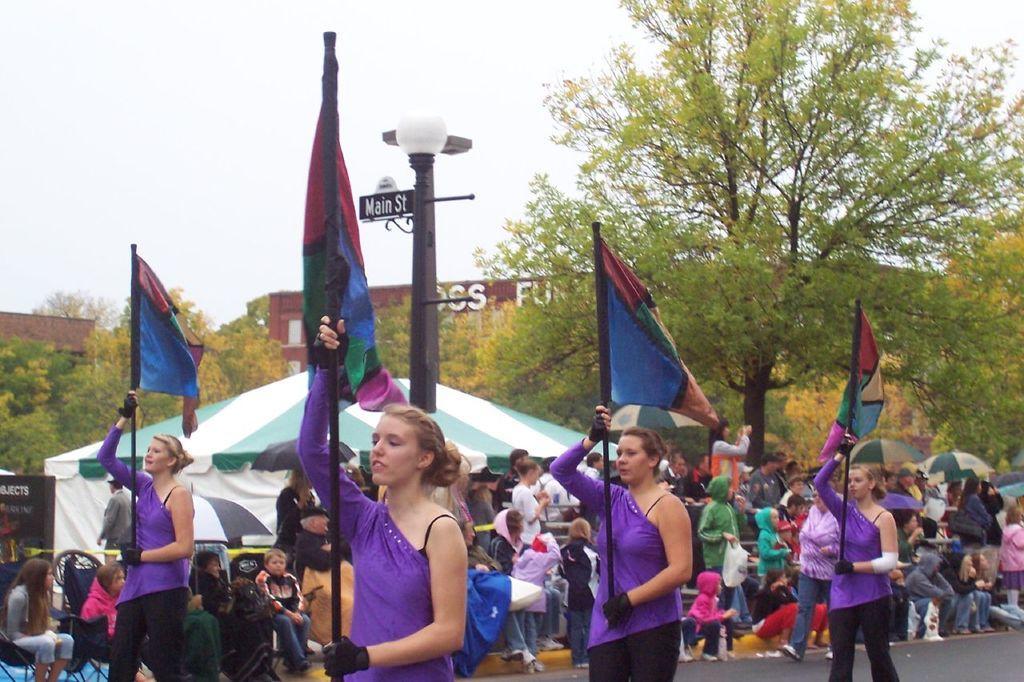Describe this image in one or two sentences. In this image there are few people in which few of them are holding flags, there are umbrellas, a tent, few buildings, few trees, chairs and the sky. 